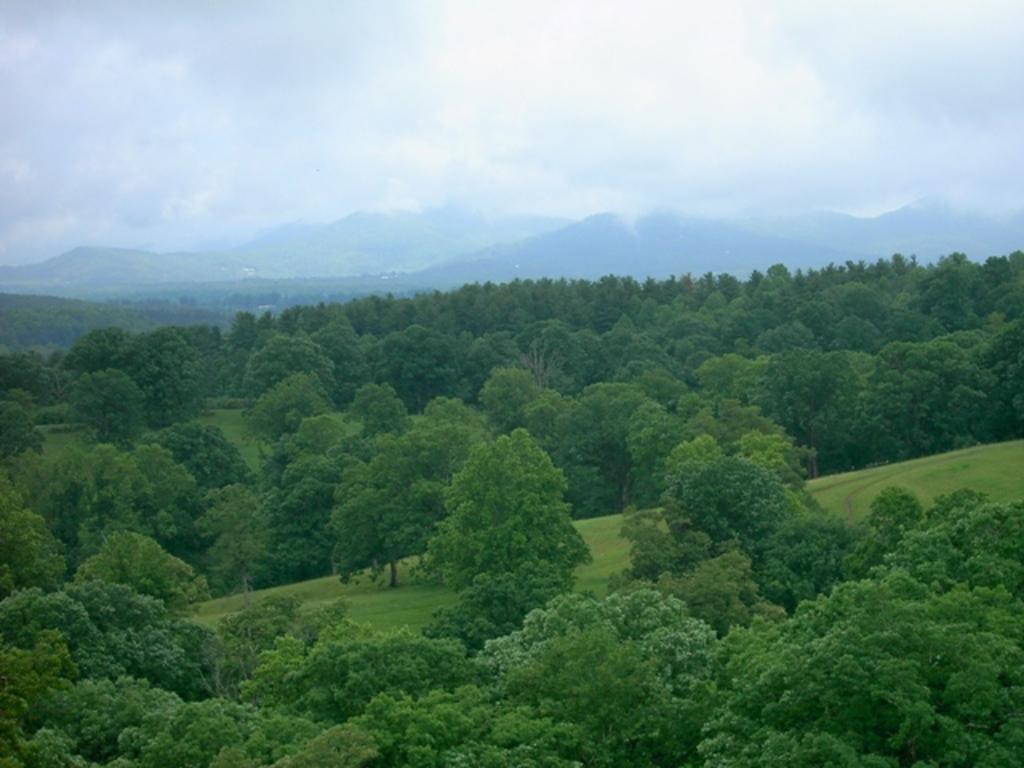In one or two sentences, can you explain what this image depicts? In this picture we can observe some trees. In the background there are hills and some fog. We can observe a sky with clouds. 